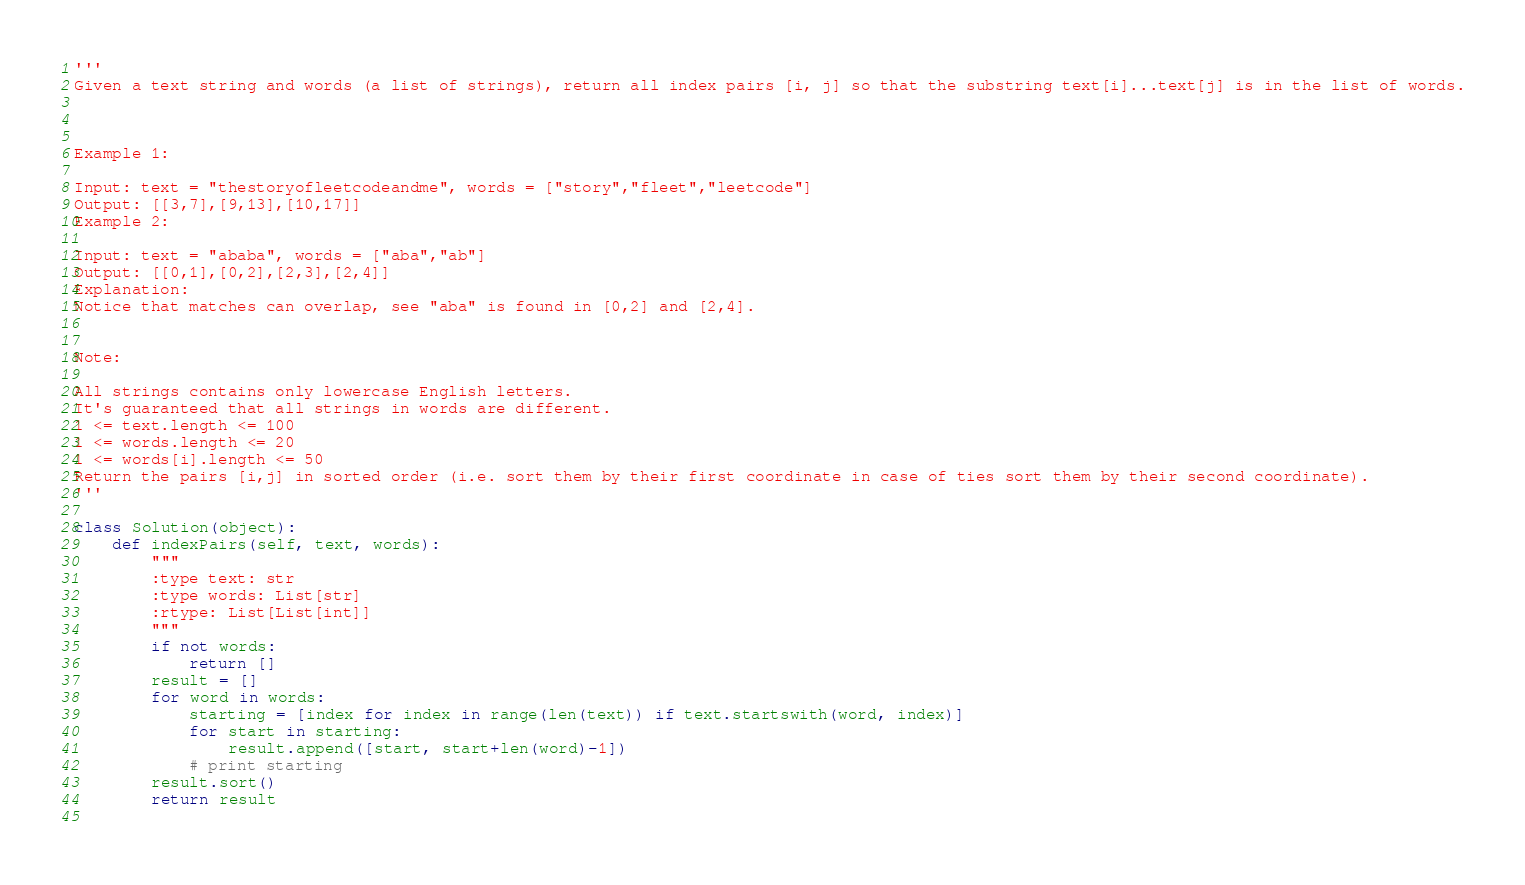Convert code to text. <code><loc_0><loc_0><loc_500><loc_500><_Python_>'''
Given a text string and words (a list of strings), return all index pairs [i, j] so that the substring text[i]...text[j] is in the list of words.

 

Example 1:

Input: text = "thestoryofleetcodeandme", words = ["story","fleet","leetcode"]
Output: [[3,7],[9,13],[10,17]]
Example 2:

Input: text = "ababa", words = ["aba","ab"]
Output: [[0,1],[0,2],[2,3],[2,4]]
Explanation: 
Notice that matches can overlap, see "aba" is found in [0,2] and [2,4].
 

Note:

All strings contains only lowercase English letters.
It's guaranteed that all strings in words are different.
1 <= text.length <= 100
1 <= words.length <= 20
1 <= words[i].length <= 50
Return the pairs [i,j] in sorted order (i.e. sort them by their first coordinate in case of ties sort them by their second coordinate).
'''

class Solution(object):
    def indexPairs(self, text, words):
        """
        :type text: str
        :type words: List[str]
        :rtype: List[List[int]]
        """
        if not words:
            return []
        result = []
        for word in words:
            starting = [index for index in range(len(text)) if text.startswith(word, index)]
            for start in starting:
                result.append([start, start+len(word)-1])
            # print starting
        result.sort()
        return result
            </code> 